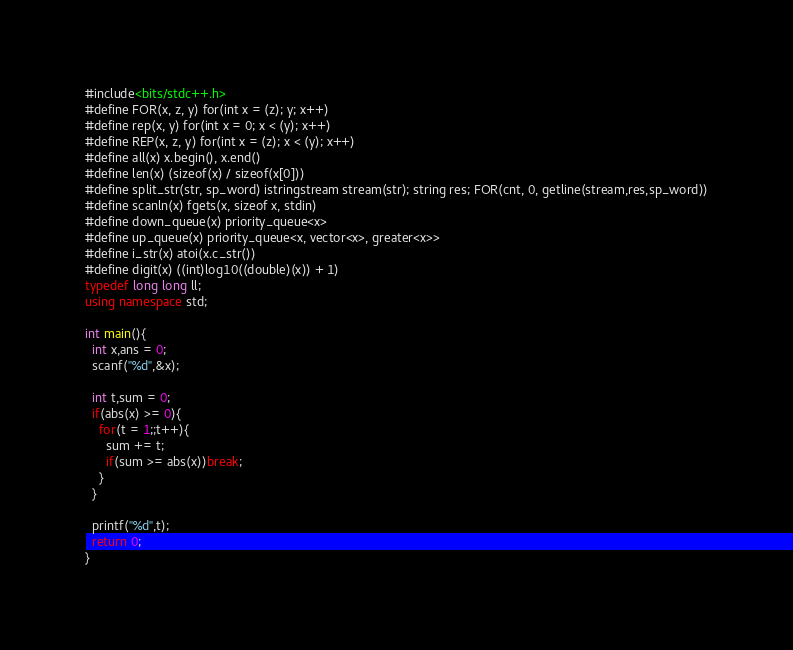<code> <loc_0><loc_0><loc_500><loc_500><_C++_>#include<bits/stdc++.h>
#define FOR(x, z, y) for(int x = (z); y; x++)
#define rep(x, y) for(int x = 0; x < (y); x++)
#define REP(x, z, y) for(int x = (z); x < (y); x++)
#define all(x) x.begin(), x.end()
#define len(x) (sizeof(x) / sizeof(x[0]))
#define split_str(str, sp_word) istringstream stream(str); string res; FOR(cnt, 0, getline(stream,res,sp_word))
#define scanln(x) fgets(x, sizeof x, stdin)
#define down_queue(x) priority_queue<x>
#define up_queue(x) priority_queue<x, vector<x>, greater<x>>
#define i_str(x) atoi(x.c_str())
#define digit(x) ((int)log10((double)(x)) + 1)
typedef long long ll;
using namespace std;

int main(){
  int x,ans = 0;
  scanf("%d",&x);
  
  int t,sum = 0;
  if(abs(x) >= 0){
    for(t = 1;;t++){
      sum += t;
      if(sum >= abs(x))break;
    }
  }

  printf("%d",t);
  return 0;
}</code> 